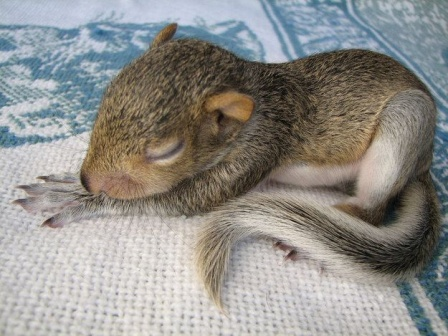What do you think the baby squirrel is dreaming about? In its peaceful slumber, the baby squirrel might be dreaming of playful adventures in a sun-dappled forest. It imagines scampering up tall oaks, leaping from branch to branch with effortless grace. In its dream, it discovers hidden treasures of acorns buried beneath the fallen leaves, and it enjoys the sweet, nutty feast. Perhaps it envisions friendly encounters with fellow forest creatures, like curious rabbits and chirping birds, turning each day into a joyous escapade. The soft murmur of the forest, accompanied by the rustling leaves and distant bird songs, further lulls the baby squirrel into a comforting, dreamlike state, where all is well in its tiny world. 